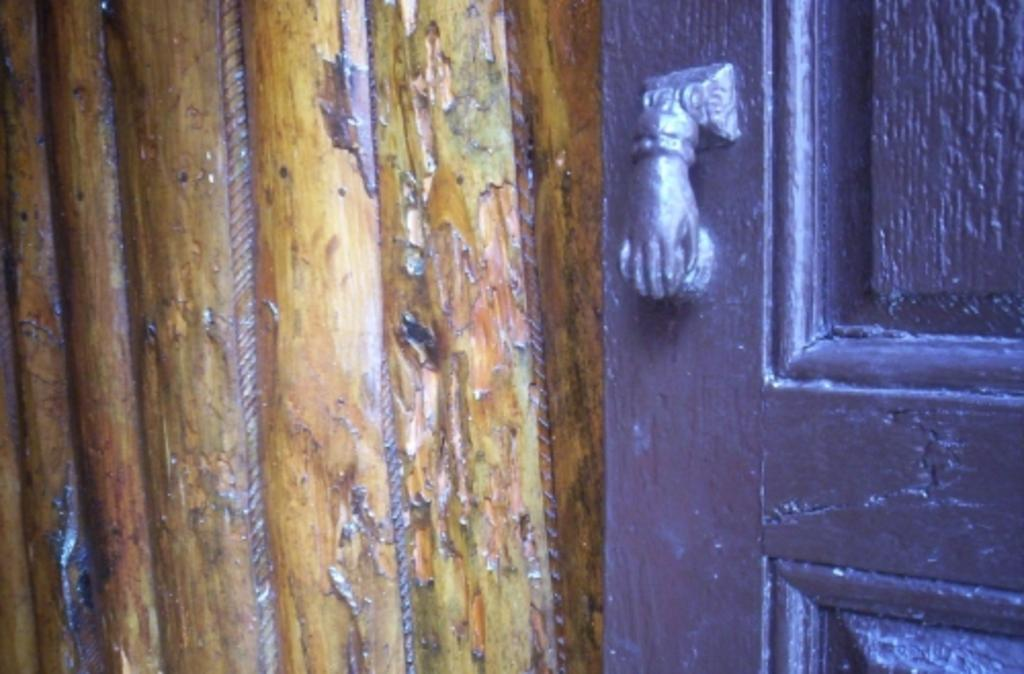What is located on the right side of the image? There is a door on the right side of the image. What is on the left side of the image? There is a wooden plank on the left side of the image. How many toes can be seen on the person in the image? There is no person present in the image, so no toes can be seen. What direction does the image turn to reveal more details? The image is a static representation and does not turn in any direction. 